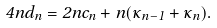<formula> <loc_0><loc_0><loc_500><loc_500>4 n d _ { n } = 2 n c _ { n } + n ( \kappa _ { n - 1 } + \kappa _ { n } ) .</formula> 